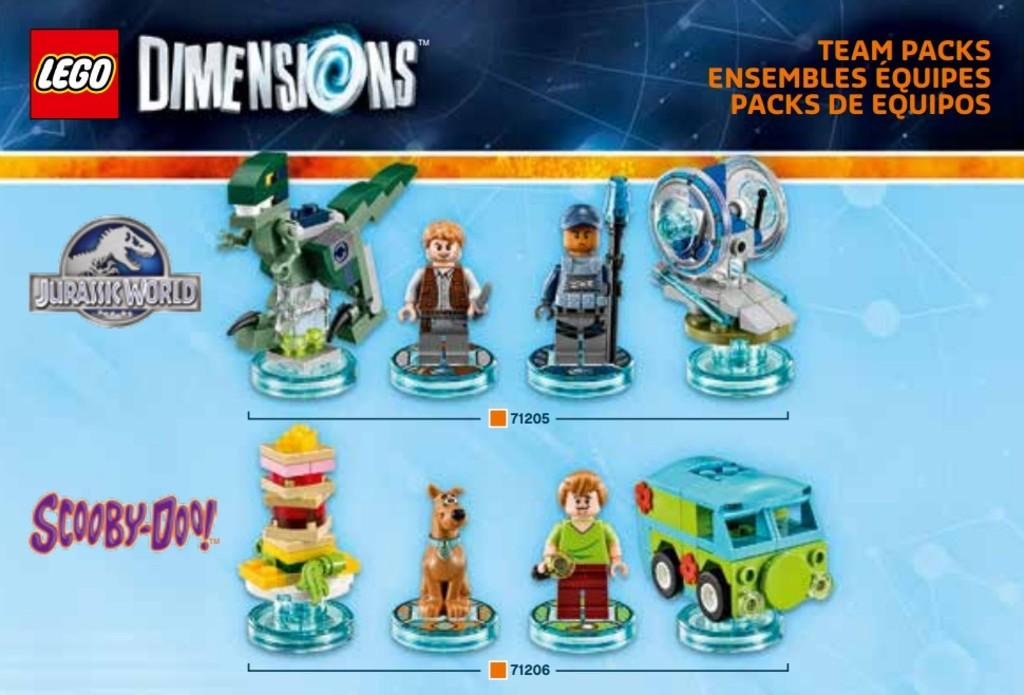What is the main subject in the center of the image? There is a poster in the center of the image. What can be found on the poster? The poster contains text, logos, and images of toys. Is there any smoke coming from the toys in the image? There is no smoke present in the image, as it only contains a poster with text, logos, and images of toys. 